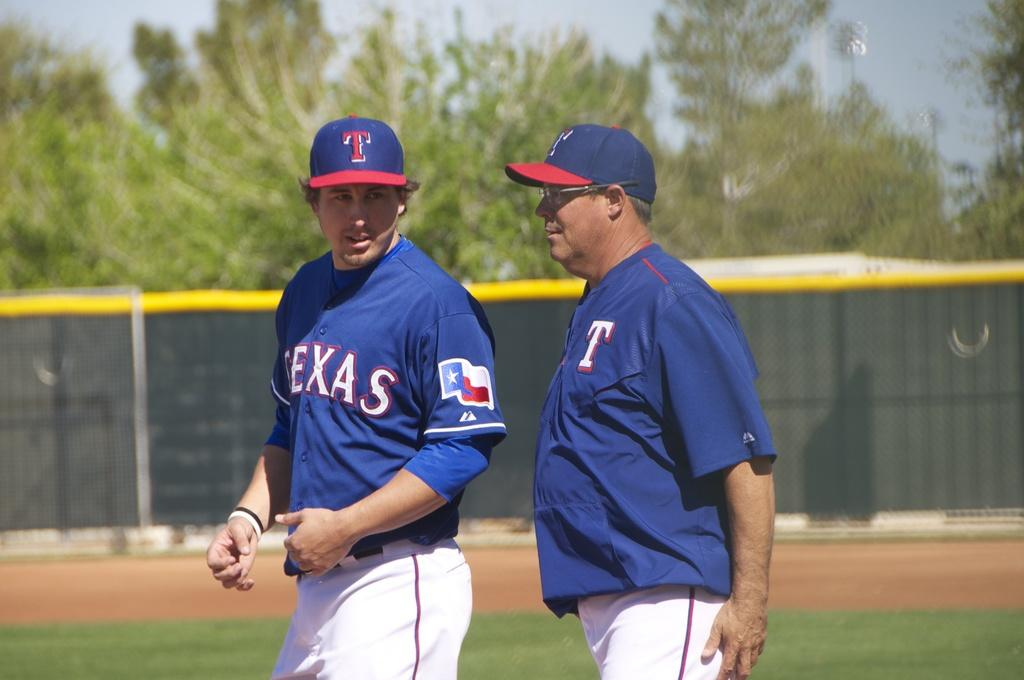<image>
Relay a brief, clear account of the picture shown. A member of the Texas team talks to a coach on the field. 